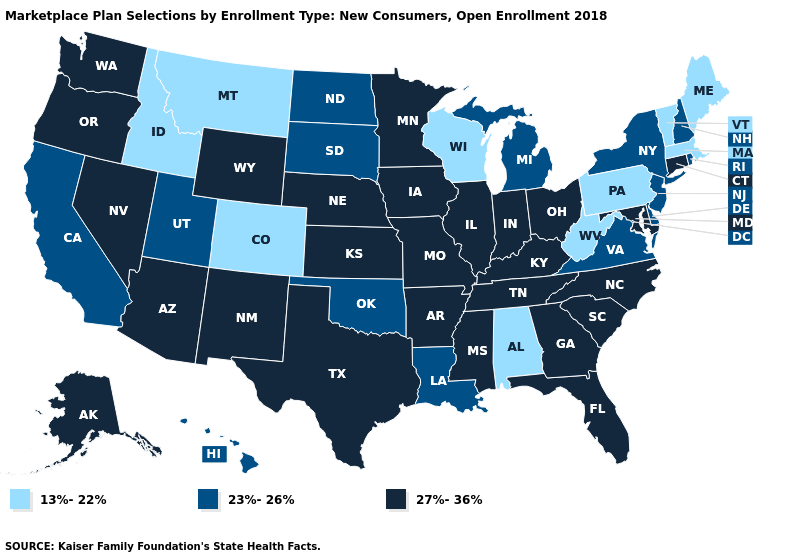What is the lowest value in the West?
Concise answer only. 13%-22%. Name the states that have a value in the range 13%-22%?
Quick response, please. Alabama, Colorado, Idaho, Maine, Massachusetts, Montana, Pennsylvania, Vermont, West Virginia, Wisconsin. Among the states that border Delaware , does Pennsylvania have the lowest value?
Quick response, please. Yes. What is the value of Maine?
Quick response, please. 13%-22%. What is the value of Maryland?
Answer briefly. 27%-36%. What is the value of Vermont?
Answer briefly. 13%-22%. Does Pennsylvania have a lower value than West Virginia?
Give a very brief answer. No. What is the value of New Mexico?
Concise answer only. 27%-36%. Name the states that have a value in the range 27%-36%?
Quick response, please. Alaska, Arizona, Arkansas, Connecticut, Florida, Georgia, Illinois, Indiana, Iowa, Kansas, Kentucky, Maryland, Minnesota, Mississippi, Missouri, Nebraska, Nevada, New Mexico, North Carolina, Ohio, Oregon, South Carolina, Tennessee, Texas, Washington, Wyoming. Name the states that have a value in the range 23%-26%?
Be succinct. California, Delaware, Hawaii, Louisiana, Michigan, New Hampshire, New Jersey, New York, North Dakota, Oklahoma, Rhode Island, South Dakota, Utah, Virginia. Does Nebraska have the lowest value in the USA?
Short answer required. No. Name the states that have a value in the range 13%-22%?
Be succinct. Alabama, Colorado, Idaho, Maine, Massachusetts, Montana, Pennsylvania, Vermont, West Virginia, Wisconsin. Does Connecticut have the highest value in the Northeast?
Write a very short answer. Yes. Among the states that border Missouri , which have the lowest value?
Answer briefly. Oklahoma. What is the lowest value in states that border Alabama?
Answer briefly. 27%-36%. 